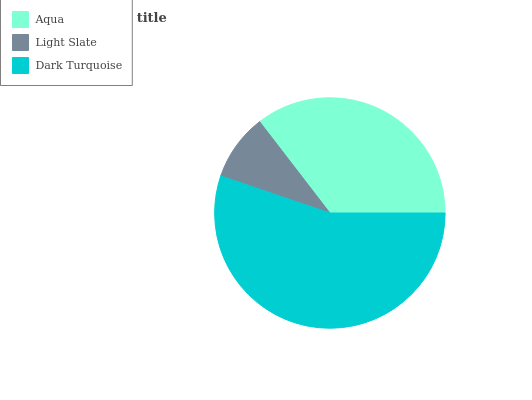Is Light Slate the minimum?
Answer yes or no. Yes. Is Dark Turquoise the maximum?
Answer yes or no. Yes. Is Dark Turquoise the minimum?
Answer yes or no. No. Is Light Slate the maximum?
Answer yes or no. No. Is Dark Turquoise greater than Light Slate?
Answer yes or no. Yes. Is Light Slate less than Dark Turquoise?
Answer yes or no. Yes. Is Light Slate greater than Dark Turquoise?
Answer yes or no. No. Is Dark Turquoise less than Light Slate?
Answer yes or no. No. Is Aqua the high median?
Answer yes or no. Yes. Is Aqua the low median?
Answer yes or no. Yes. Is Dark Turquoise the high median?
Answer yes or no. No. Is Dark Turquoise the low median?
Answer yes or no. No. 